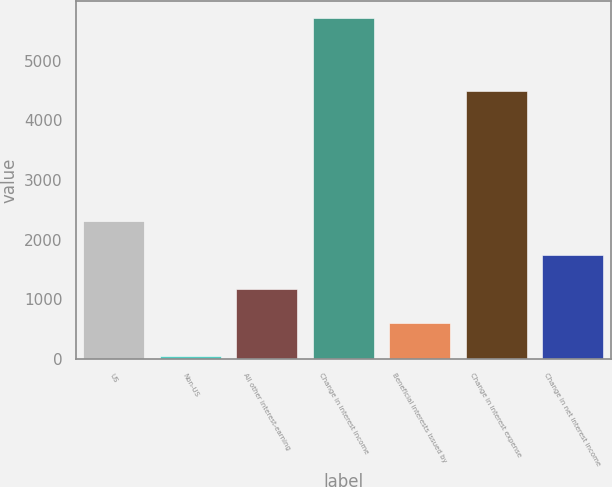Convert chart to OTSL. <chart><loc_0><loc_0><loc_500><loc_500><bar_chart><fcel>US<fcel>Non-US<fcel>All other interest-earning<fcel>Change in interest income<fcel>Beneficial interests issued by<fcel>Change in interest expense<fcel>Change in net interest income<nl><fcel>2310.4<fcel>44<fcel>1177.2<fcel>5710<fcel>610.6<fcel>4490<fcel>1743.8<nl></chart> 